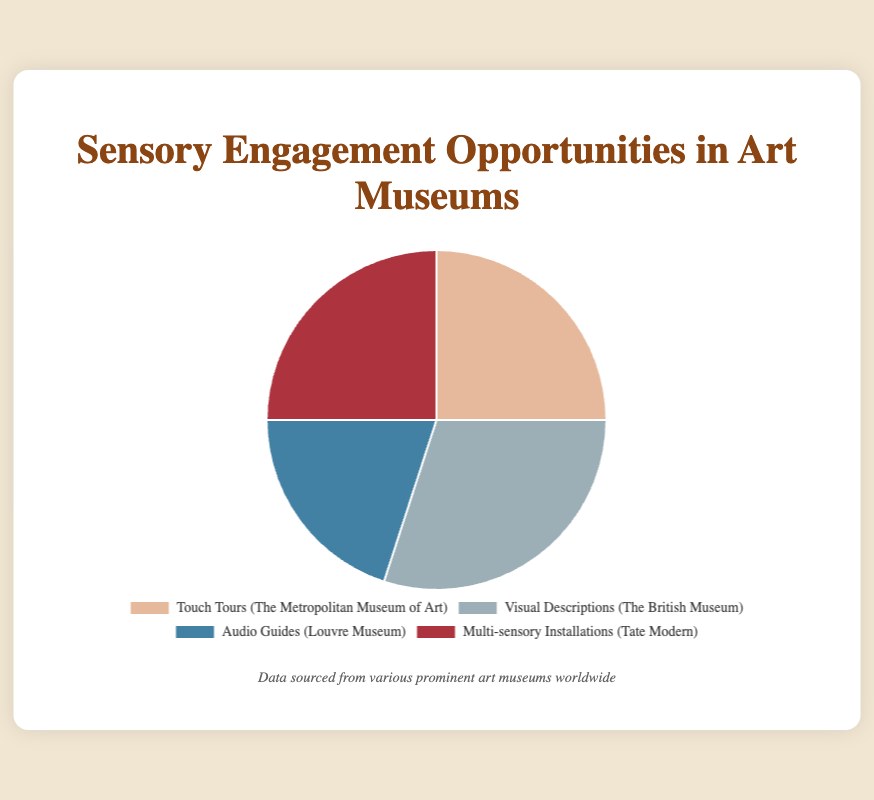What's the total percentage of sensory engagement opportunities provided by Touch Tours and Multi-sensory Installations combined? To find this, add the percentage of Touch Tours (25%) and Multi-sensory Installations (25%). So, 25 + 25 = 50
Answer: 50 Which sensory engagement opportunity is offered the most according to the pie chart? The largest percentage in the pie chart is 30% for Visual Descriptions at The British Museum
Answer: Visual Descriptions Are there any sensory engagement opportunities that have equal representation in the pie chart? Yes, Touch Tours and Multi-sensory Installations both have a percentage of 25% each
Answer: Yes How much greater is the percentage of Visual Descriptions compared to Audio Guides? Visual Descriptions have 30% and Audio Guides have 20%. The difference is 30 - 20 = 10
Answer: 10 Which sensory engagement opportunities have equal percentages? By looking at the pie chart, Touch Tours and Multi-sensory Installations both represent 25% each
Answer: Touch Tours and Multi-sensory Installations What is the average percentage of all sensory engagement opportunities presented in the pie chart? Add all percentages: 25 (Touch Tours) + 30 (Visual Descriptions) + 20 (Audio Guides) + 25 (Multi-sensory Installations) = 100. Divide by 4 to find the average: 100 / 4 = 25
Answer: 25 What is the visual color representation of the Audio Guides segment in the pie chart? The Audio Guides segment is represented by the color blue in the pie chart as depicted in the label layout
Answer: Blue Is the percentage of Touch Tours greater than or equal to the percentage of Audio Guides? The percentage for Touch Tours is 25% and for Audio Guides is 20%. Since 25 is greater than 20, the statement is true
Answer: Yes Which segment of the pie chart represents the color corresponding to Visual Descriptions? The Visual Descriptions segment is represented by the gray color in the pie chart
Answer: Gray 